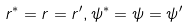Convert formula to latex. <formula><loc_0><loc_0><loc_500><loc_500>r ^ { * } = r = r ^ { \prime } , \psi ^ { * } = \psi = \psi ^ { \prime }</formula> 